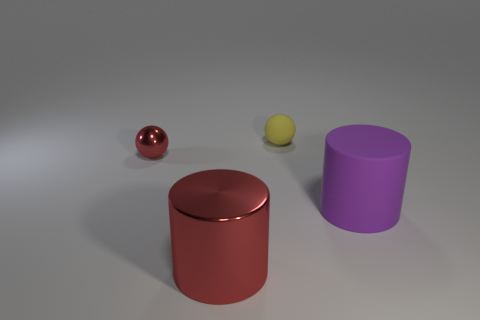There is a red thing to the left of the big red metallic object; is its shape the same as the small matte thing?
Ensure brevity in your answer.  Yes. What size is the metal sphere that is the same color as the big metal cylinder?
Your response must be concise. Small. What number of brown objects are metallic balls or big things?
Keep it short and to the point. 0. What number of other things are the same shape as the small red thing?
Your response must be concise. 1. There is a thing that is both on the right side of the large shiny cylinder and on the left side of the matte cylinder; what is its shape?
Offer a terse response. Sphere. Are there any matte balls on the left side of the small matte thing?
Your answer should be very brief. No. The rubber object that is the same shape as the tiny shiny object is what size?
Provide a short and direct response. Small. Is there anything else that is the same size as the matte cylinder?
Your response must be concise. Yes. Do the tiny metal thing and the large rubber thing have the same shape?
Provide a succinct answer. No. How big is the thing that is behind the red object behind the big red cylinder?
Provide a succinct answer. Small. 